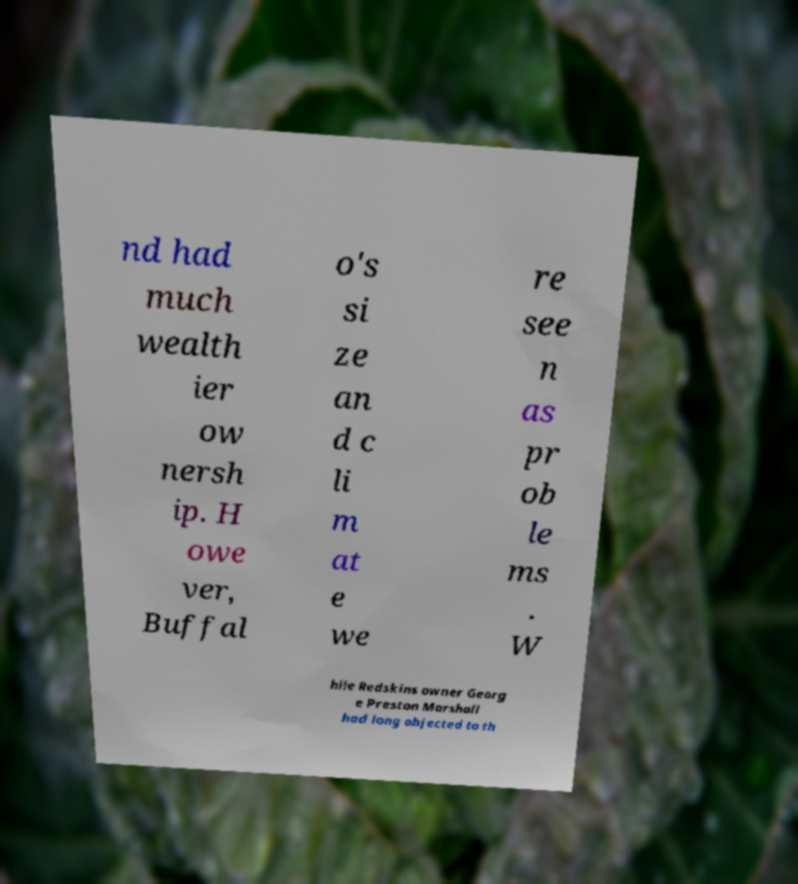There's text embedded in this image that I need extracted. Can you transcribe it verbatim? nd had much wealth ier ow nersh ip. H owe ver, Buffal o's si ze an d c li m at e we re see n as pr ob le ms . W hile Redskins owner Georg e Preston Marshall had long objected to th 